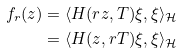<formula> <loc_0><loc_0><loc_500><loc_500>f _ { r } ( z ) & = \langle H ( r z , T ) \xi , \xi \rangle _ { \mathcal { H } } \\ & = \langle H ( z , r T ) \xi , \xi \rangle _ { \mathcal { H } }</formula> 